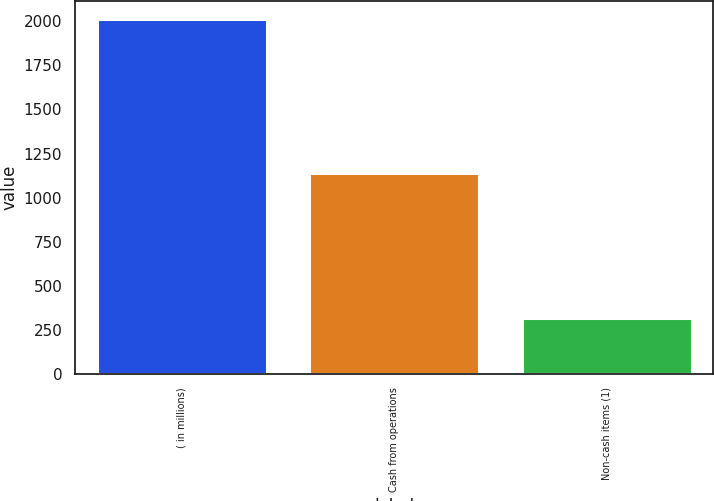<chart> <loc_0><loc_0><loc_500><loc_500><bar_chart><fcel>( in millions)<fcel>Cash from operations<fcel>Non-cash items (1)<nl><fcel>2013<fcel>1140<fcel>316<nl></chart> 